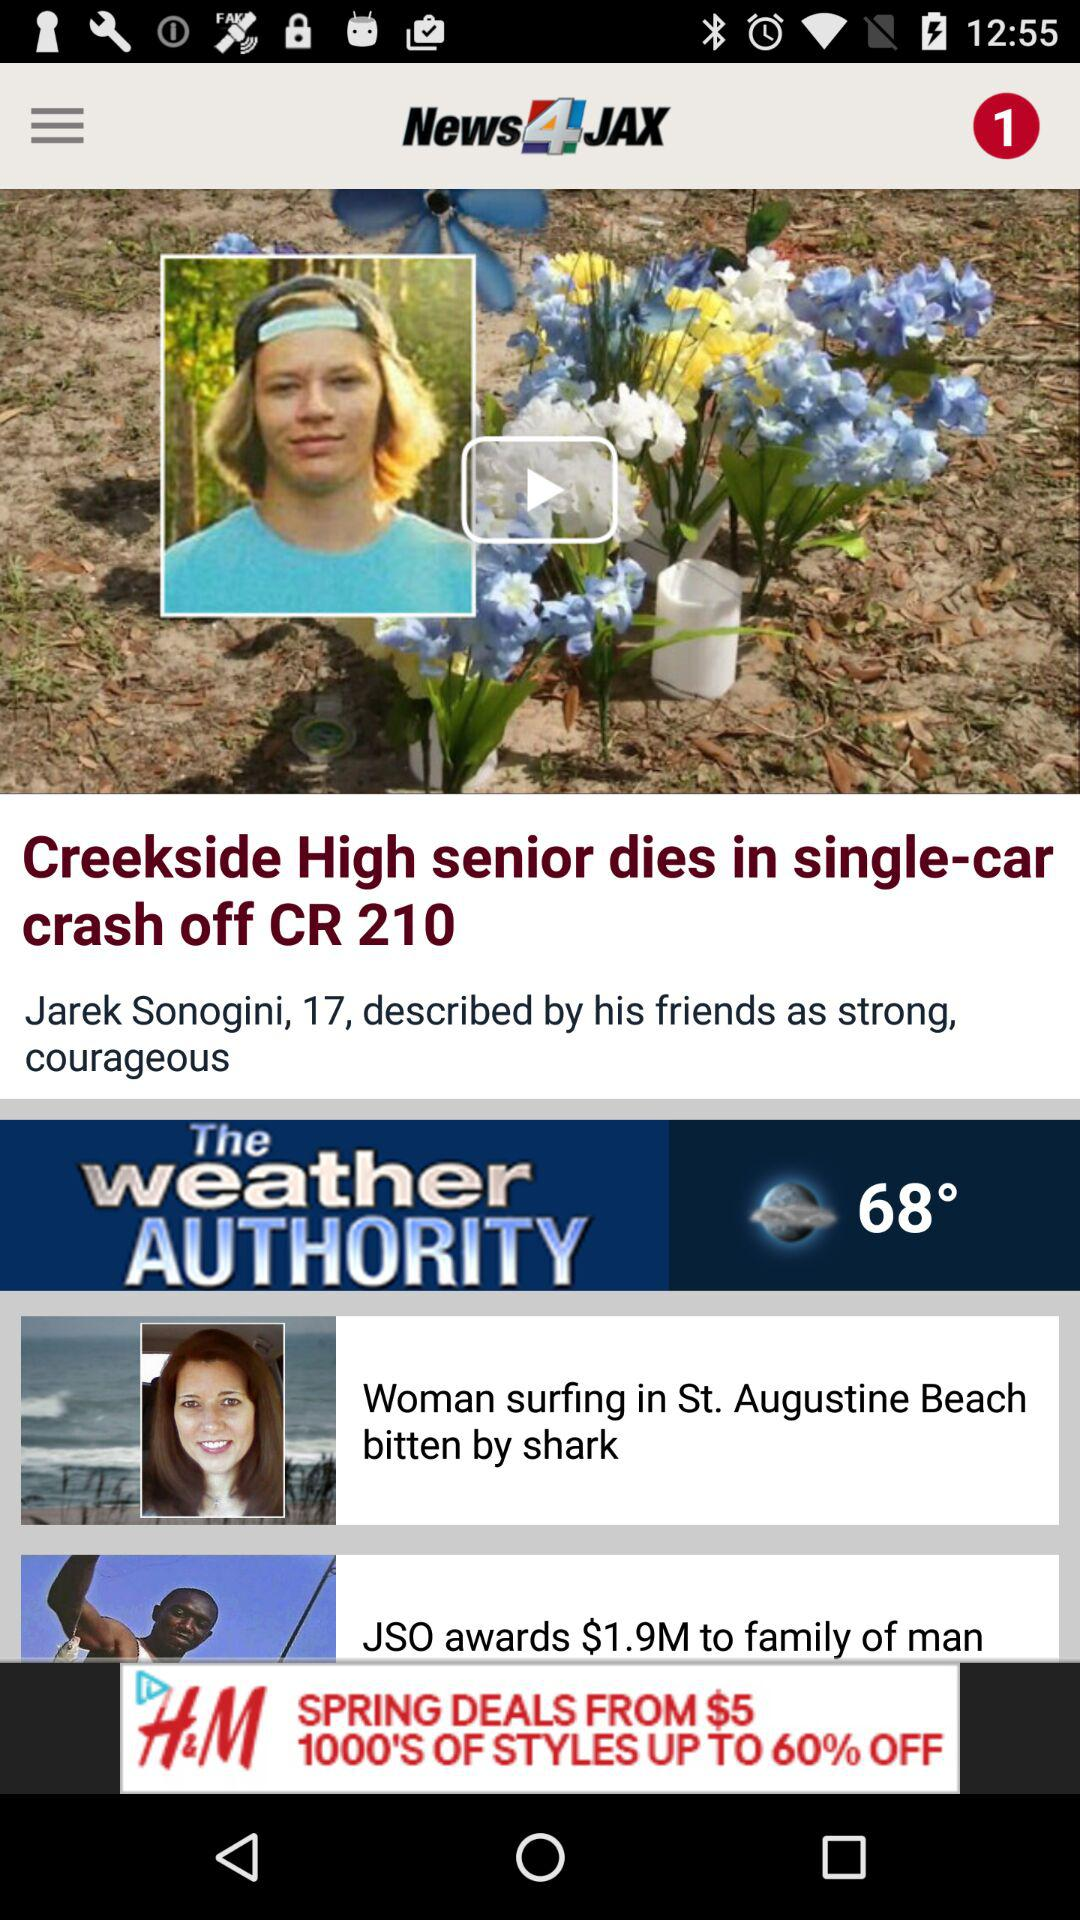How many degrees is the weather today?
Answer the question using a single word or phrase. 68° 